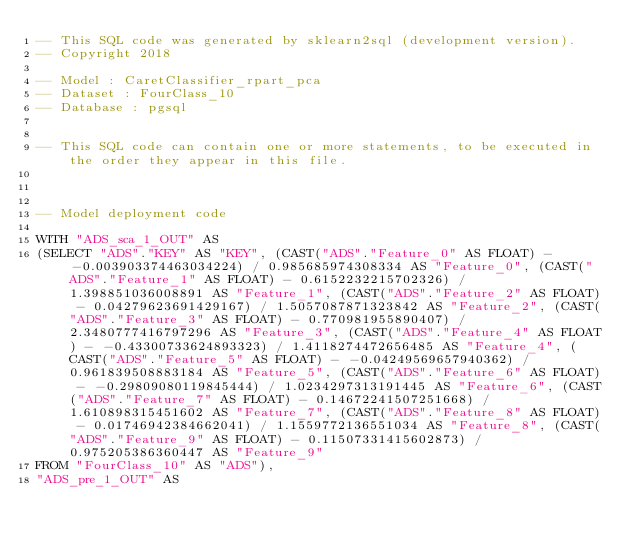Convert code to text. <code><loc_0><loc_0><loc_500><loc_500><_SQL_>-- This SQL code was generated by sklearn2sql (development version).
-- Copyright 2018

-- Model : CaretClassifier_rpart_pca
-- Dataset : FourClass_10
-- Database : pgsql


-- This SQL code can contain one or more statements, to be executed in the order they appear in this file.



-- Model deployment code

WITH "ADS_sca_1_OUT" AS 
(SELECT "ADS"."KEY" AS "KEY", (CAST("ADS"."Feature_0" AS FLOAT) - -0.003903374463034224) / 0.985685974308334 AS "Feature_0", (CAST("ADS"."Feature_1" AS FLOAT) - 0.6152232215702326) / 1.398851036008891 AS "Feature_1", (CAST("ADS"."Feature_2" AS FLOAT) - 0.04279623691429167) / 1.5057087871323842 AS "Feature_2", (CAST("ADS"."Feature_3" AS FLOAT) - 0.770981955890407) / 2.3480777416797296 AS "Feature_3", (CAST("ADS"."Feature_4" AS FLOAT) - -0.43300733624893323) / 1.4118274472656485 AS "Feature_4", (CAST("ADS"."Feature_5" AS FLOAT) - -0.04249569657940362) / 0.961839508883184 AS "Feature_5", (CAST("ADS"."Feature_6" AS FLOAT) - -0.29809080119845444) / 1.0234297313191445 AS "Feature_6", (CAST("ADS"."Feature_7" AS FLOAT) - 0.14672241507251668) / 1.610898315451602 AS "Feature_7", (CAST("ADS"."Feature_8" AS FLOAT) - 0.01746942384662041) / 1.1559772136551034 AS "Feature_8", (CAST("ADS"."Feature_9" AS FLOAT) - 0.11507331415602873) / 0.975205386360447 AS "Feature_9" 
FROM "FourClass_10" AS "ADS"), 
"ADS_pre_1_OUT" AS </code> 